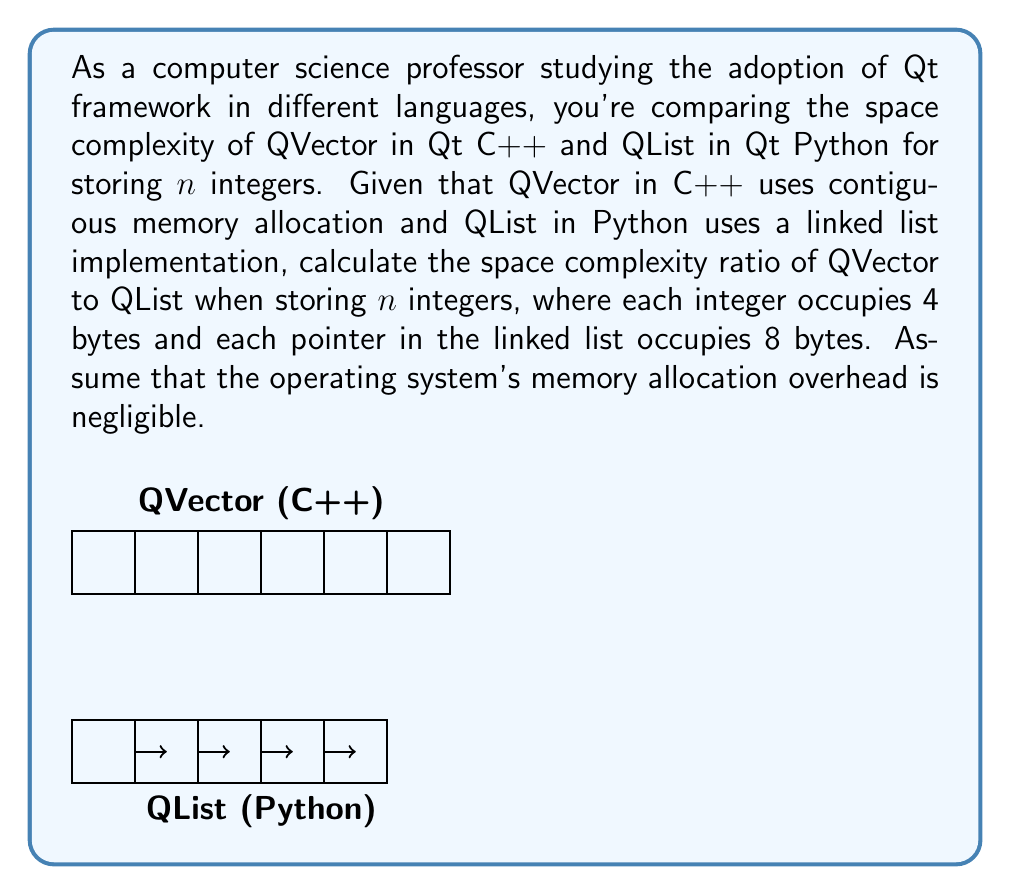Could you help me with this problem? Let's approach this step-by-step:

1) For QVector in C++:
   - Space required = $4n$ bytes (contiguous allocation of $n$ integers)
   
2) For QList in Python:
   - Each node in the linked list contains:
     * An integer (4 bytes)
     * A pointer to the next node (8 bytes)
   - Total space per node = 4 + 8 = 12 bytes
   - Space required for $n$ integers = $12n$ bytes

3) To calculate the ratio, we divide the space required by QVector by the space required by QList:

   $$\text{Ratio} = \frac{\text{Space(QVector)}}{\text{Space(QList)}} = \frac{4n}{12n} = \frac{1}{3}$$

4) This ratio simplifies to $1:3$ or $\frac{1}{3}$.

Thus, QVector in C++ uses one-third of the space used by QList in Python for storing the same number of integers.
Answer: $\frac{1}{3}$ 